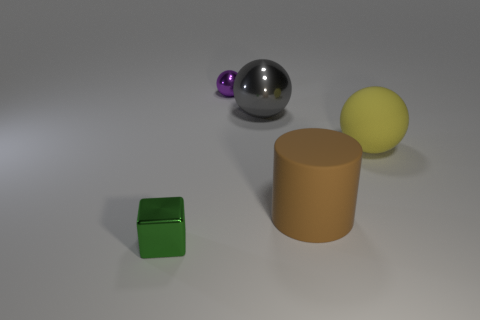Subtract all purple blocks. Subtract all cyan cylinders. How many blocks are left? 1 Add 2 big cyan rubber blocks. How many objects exist? 7 Subtract all spheres. How many objects are left? 2 Add 1 cyan matte cylinders. How many cyan matte cylinders exist? 1 Subtract 0 cyan cubes. How many objects are left? 5 Subtract all gray shiny things. Subtract all purple metal things. How many objects are left? 3 Add 2 large metal things. How many large metal things are left? 3 